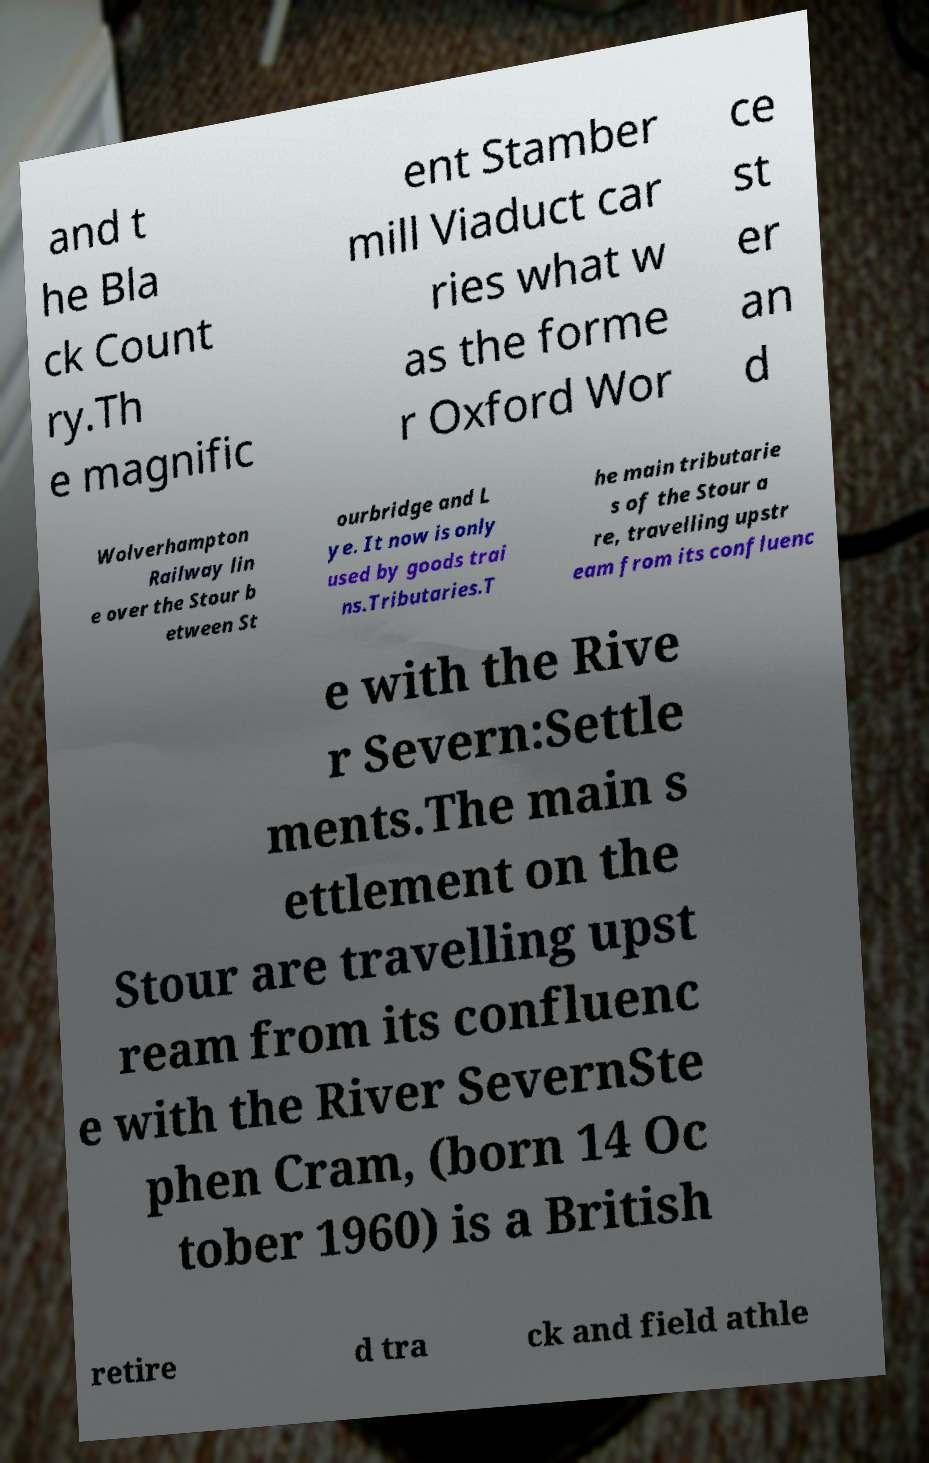There's text embedded in this image that I need extracted. Can you transcribe it verbatim? and t he Bla ck Count ry.Th e magnific ent Stamber mill Viaduct car ries what w as the forme r Oxford Wor ce st er an d Wolverhampton Railway lin e over the Stour b etween St ourbridge and L ye. It now is only used by goods trai ns.Tributaries.T he main tributarie s of the Stour a re, travelling upstr eam from its confluenc e with the Rive r Severn:Settle ments.The main s ettlement on the Stour are travelling upst ream from its confluenc e with the River SevernSte phen Cram, (born 14 Oc tober 1960) is a British retire d tra ck and field athle 